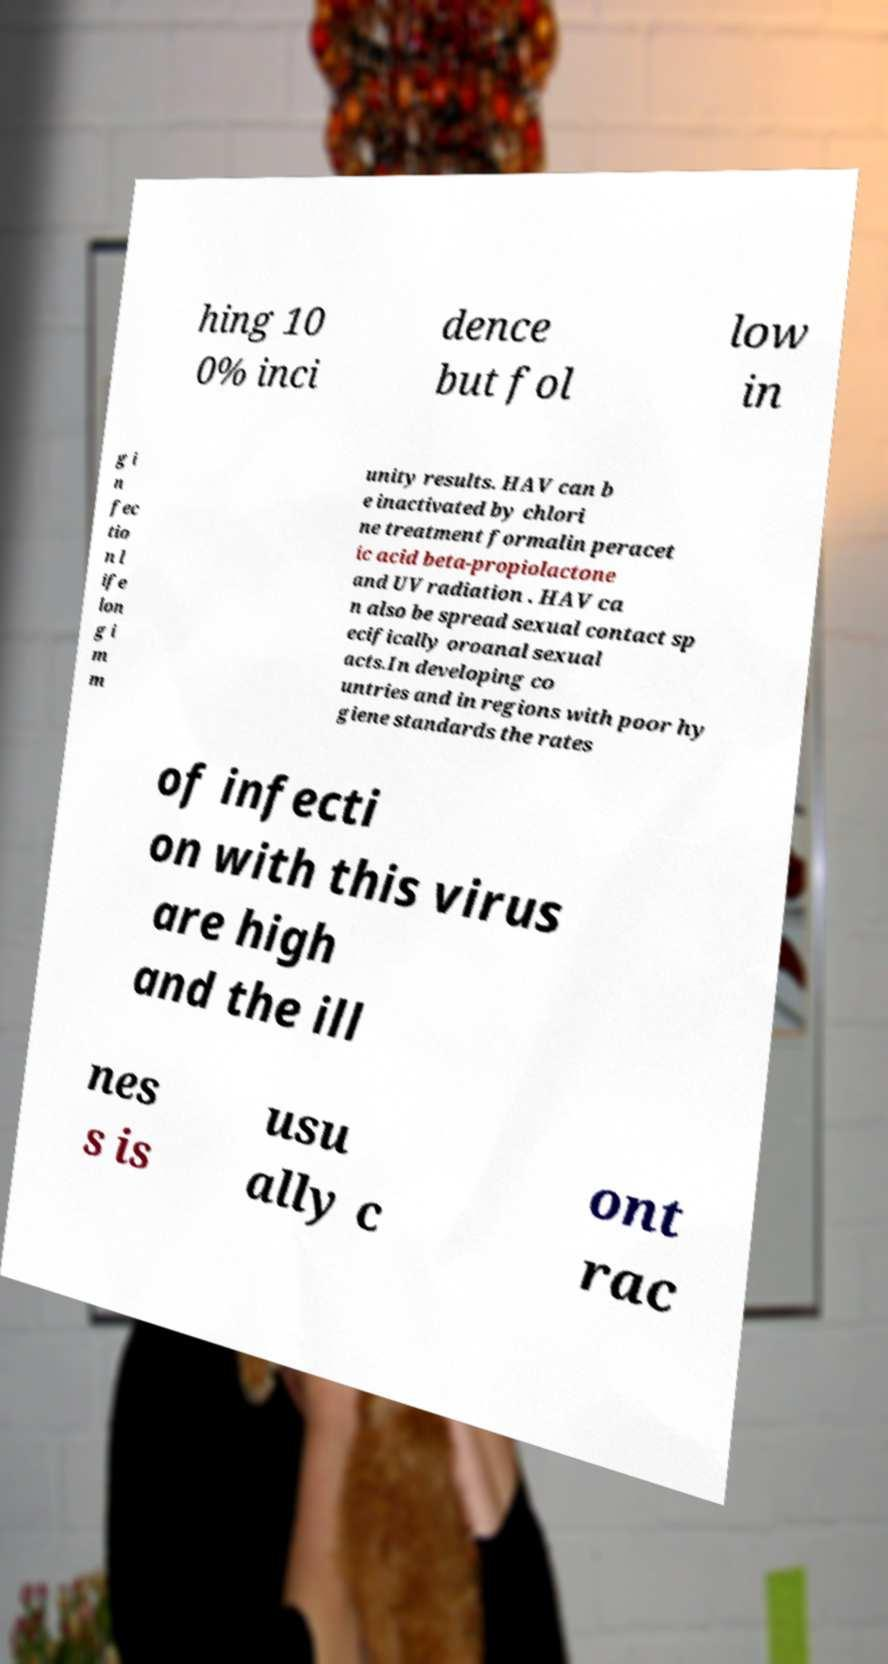Please read and relay the text visible in this image. What does it say? hing 10 0% inci dence but fol low in g i n fec tio n l ife lon g i m m unity results. HAV can b e inactivated by chlori ne treatment formalin peracet ic acid beta-propiolactone and UV radiation . HAV ca n also be spread sexual contact sp ecifically oroanal sexual acts.In developing co untries and in regions with poor hy giene standards the rates of infecti on with this virus are high and the ill nes s is usu ally c ont rac 